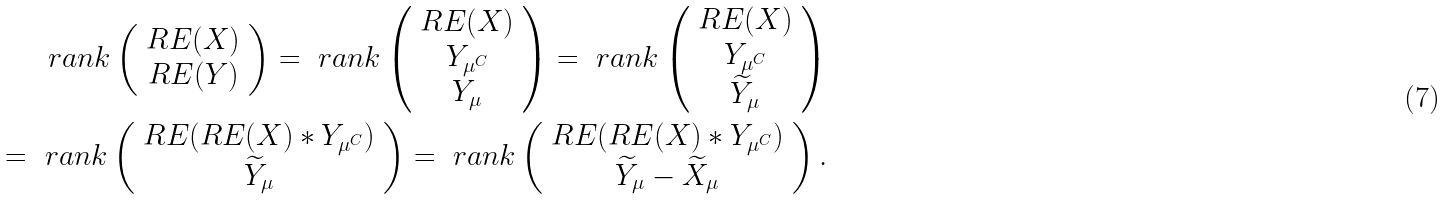Convert formula to latex. <formula><loc_0><loc_0><loc_500><loc_500>\ r a n k \left ( \begin{array} { c } R E ( X ) \\ R E ( Y ) \end{array} \right ) = \ r a n k \left ( \begin{array} { c } R E ( X ) \\ Y _ { \mu ^ { C } } \\ Y _ { \mu } \end{array} \right ) = \ r a n k \left ( \begin{array} { c } R E ( X ) \\ Y _ { \mu ^ { C } } \\ \widetilde { Y } _ { \mu } \end{array} \right ) \\ = \ r a n k \left ( \begin{array} { c } R E ( R E ( X ) * Y _ { \mu ^ { C } } ) \\ \widetilde { Y } _ { \mu } \end{array} \right ) = \ r a n k \left ( \begin{array} { c } R E ( R E ( X ) * Y _ { \mu ^ { C } } ) \\ \widetilde { Y } _ { \mu } - \widetilde { X } _ { \mu } \end{array} \right ) .</formula> 